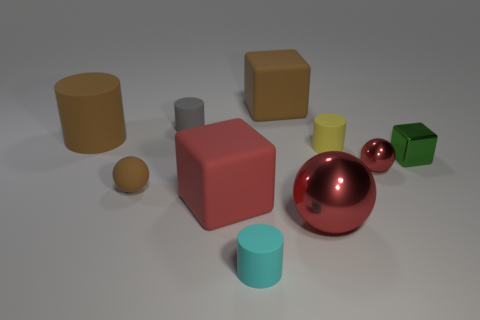Subtract all tiny yellow rubber cylinders. How many cylinders are left? 3 Subtract all gray blocks. How many red balls are left? 2 Subtract 1 spheres. How many spheres are left? 2 Subtract all brown cylinders. How many cylinders are left? 3 Subtract all spheres. How many objects are left? 7 Subtract all tiny brown objects. Subtract all big rubber things. How many objects are left? 6 Add 4 big red objects. How many big red objects are left? 6 Add 7 blue objects. How many blue objects exist? 7 Subtract 0 purple cubes. How many objects are left? 10 Subtract all blue cylinders. Subtract all green cubes. How many cylinders are left? 4 